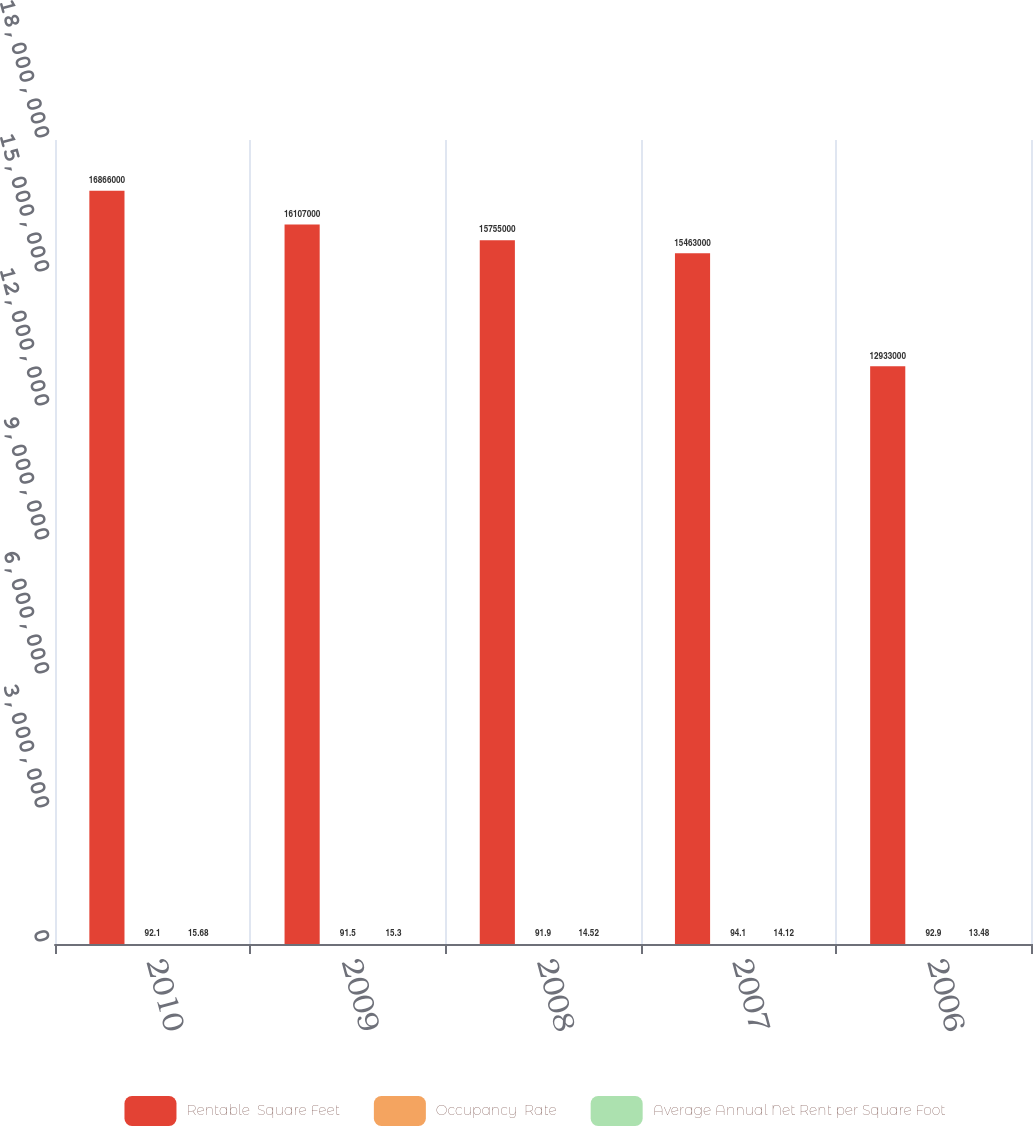Convert chart. <chart><loc_0><loc_0><loc_500><loc_500><stacked_bar_chart><ecel><fcel>2010<fcel>2009<fcel>2008<fcel>2007<fcel>2006<nl><fcel>Rentable  Square Feet<fcel>1.6866e+07<fcel>1.6107e+07<fcel>1.5755e+07<fcel>1.5463e+07<fcel>1.2933e+07<nl><fcel>Occupancy  Rate<fcel>92.1<fcel>91.5<fcel>91.9<fcel>94.1<fcel>92.9<nl><fcel>Average Annual Net Rent per Square Foot<fcel>15.68<fcel>15.3<fcel>14.52<fcel>14.12<fcel>13.48<nl></chart> 